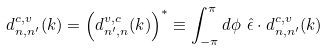<formula> <loc_0><loc_0><loc_500><loc_500>d ^ { c , v } _ { n , n ^ { \prime } } ( k ) = \left ( d ^ { v , c } _ { n ^ { \prime } , n } ( k ) \right ) ^ { * } \equiv \int _ { - \pi } ^ { \pi } d \phi \ { \hat { \epsilon } } \cdot { d } ^ { c , v } _ { n , n ^ { \prime } } ( { k } )</formula> 